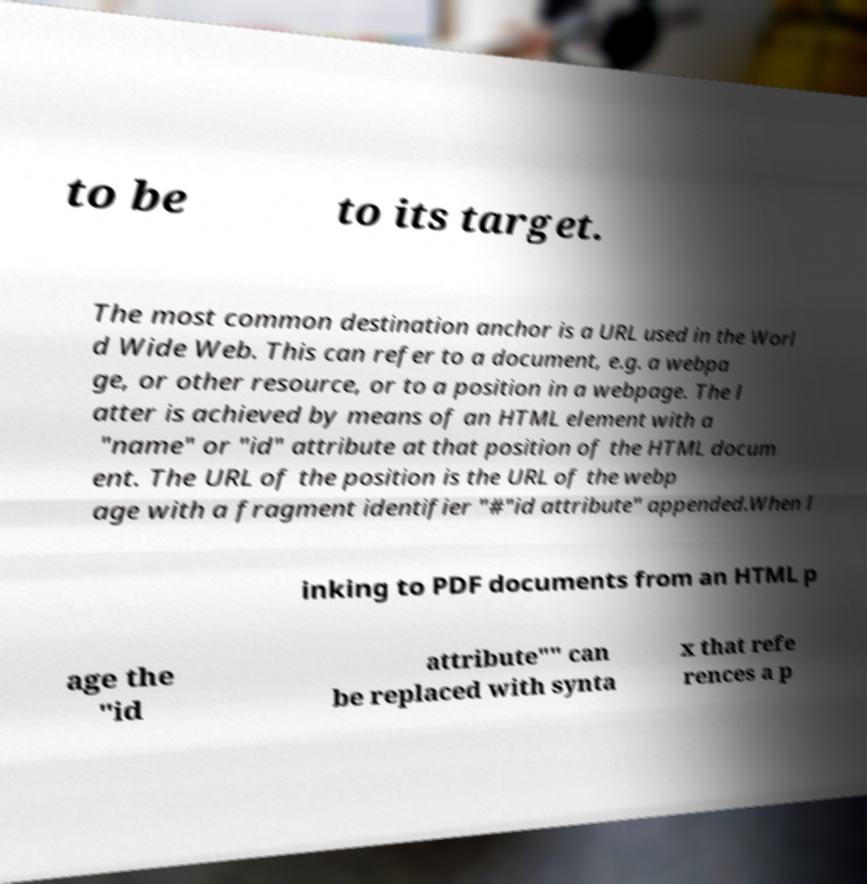For documentation purposes, I need the text within this image transcribed. Could you provide that? to be to its target. The most common destination anchor is a URL used in the Worl d Wide Web. This can refer to a document, e.g. a webpa ge, or other resource, or to a position in a webpage. The l atter is achieved by means of an HTML element with a "name" or "id" attribute at that position of the HTML docum ent. The URL of the position is the URL of the webp age with a fragment identifier "#"id attribute" appended.When l inking to PDF documents from an HTML p age the "id attribute"" can be replaced with synta x that refe rences a p 